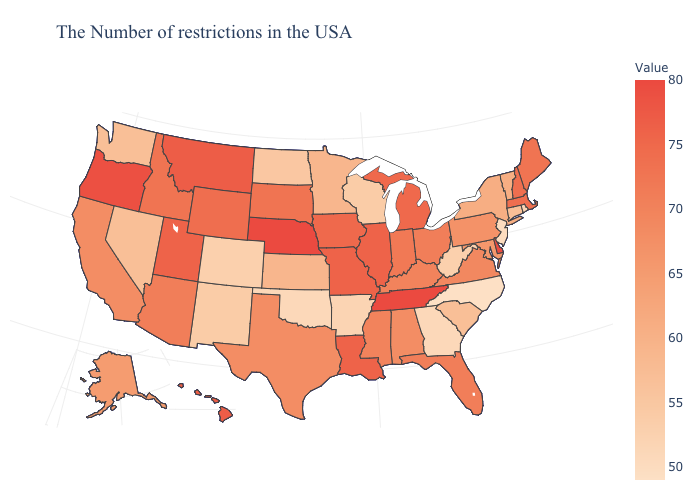Does New Mexico have a lower value than North Carolina?
Write a very short answer. No. Does Indiana have a lower value than North Dakota?
Give a very brief answer. No. Which states have the lowest value in the USA?
Answer briefly. North Carolina. Does California have a higher value than North Dakota?
Concise answer only. Yes. 